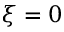Convert formula to latex. <formula><loc_0><loc_0><loc_500><loc_500>\xi = 0</formula> 